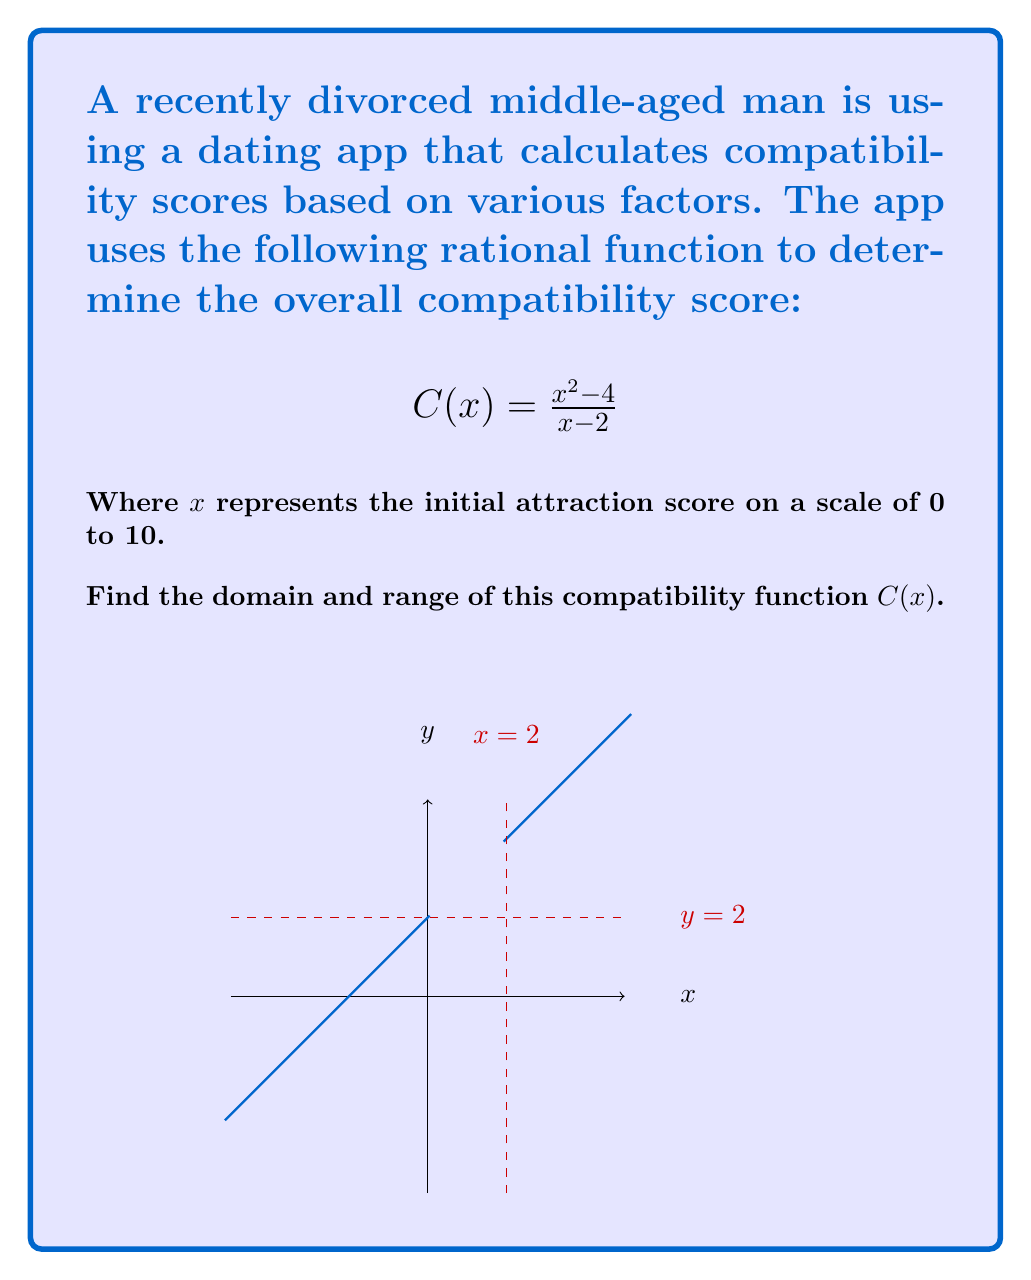Can you solve this math problem? Let's approach this step-by-step:

1) Domain:
   The domain of a rational function includes all real numbers except those that make the denominator zero.
   
   Set the denominator to zero and solve:
   $x - 2 = 0$
   $x = 2$

   Therefore, 2 is not in the domain.

2) To find the range, let's analyze the function:

   $$C(x) = \frac{x^2 - 4}{x - 2} = \frac{(x+2)(x-2)}{x-2} = x + 2$$

   This simplification is valid for all $x \neq 2$.

3) Now we can see that $C(x)$ is a linear function with a slope of 1 and a y-intercept of 2.

4) As $x$ approaches positive infinity, $C(x)$ will approach positive infinity.
   As $x$ approaches negative infinity, $C(x)$ will approach negative infinity.

5) There's a vertical asymptote at $x = 2$, but the function is defined for all other real numbers.

6) As $x$ approaches 2 from either side, $C(x)$ will approach positive or negative infinity.

7) Therefore, the range includes all real numbers except 2.
Answer: Domain: $\{x \in \mathbb{R} : x \neq 2\}$
Range: $\{y \in \mathbb{R} : y \neq 2\}$ 